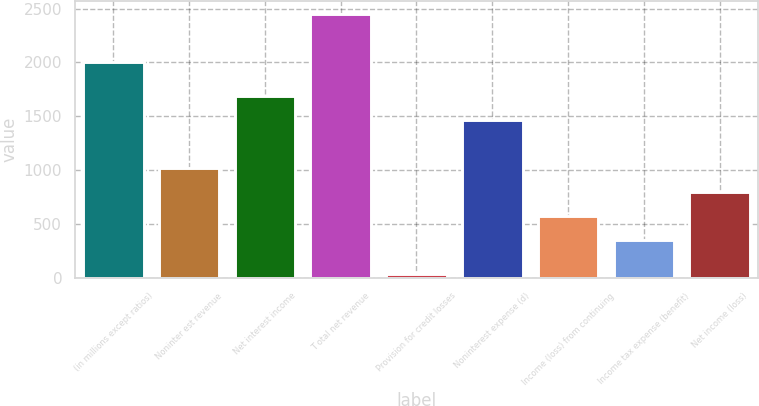<chart> <loc_0><loc_0><loc_500><loc_500><bar_chart><fcel>(in millions except ratios)<fcel>Noninter est revenue<fcel>Net interest income<fcel>T otal net revenue<fcel>Provision for credit losses<fcel>Noninterest expense (d)<fcel>Income (loss) from continuing<fcel>Income tax expense (benefit)<fcel>Net income (loss)<nl><fcel>2004<fcel>1021.1<fcel>1692.2<fcel>2451.4<fcel>41<fcel>1468.5<fcel>573.7<fcel>350<fcel>797.4<nl></chart> 